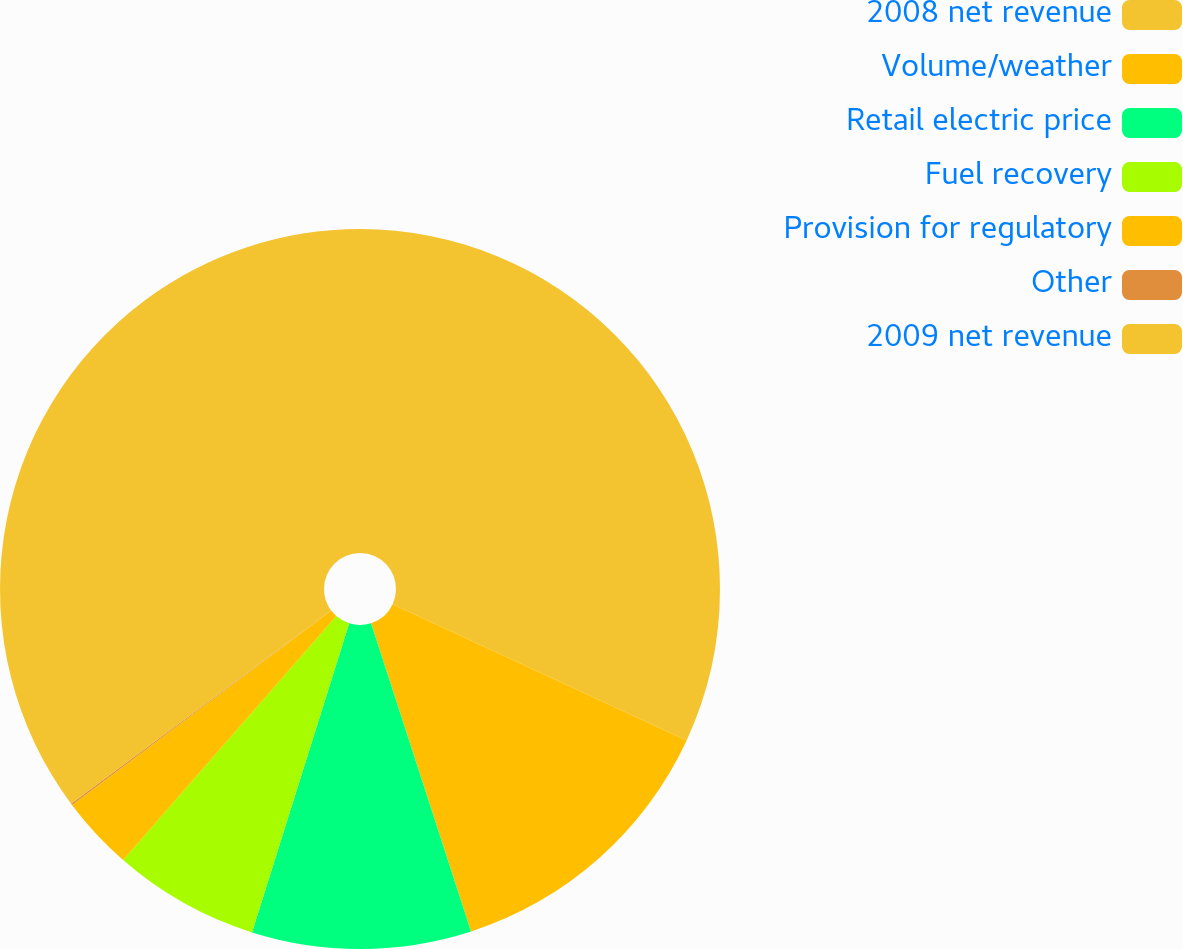<chart> <loc_0><loc_0><loc_500><loc_500><pie_chart><fcel>2008 net revenue<fcel>Volume/weather<fcel>Retail electric price<fcel>Fuel recovery<fcel>Provision for regulatory<fcel>Other<fcel>2009 net revenue<nl><fcel>31.91%<fcel>13.1%<fcel>9.84%<fcel>6.58%<fcel>3.33%<fcel>0.07%<fcel>35.17%<nl></chart> 